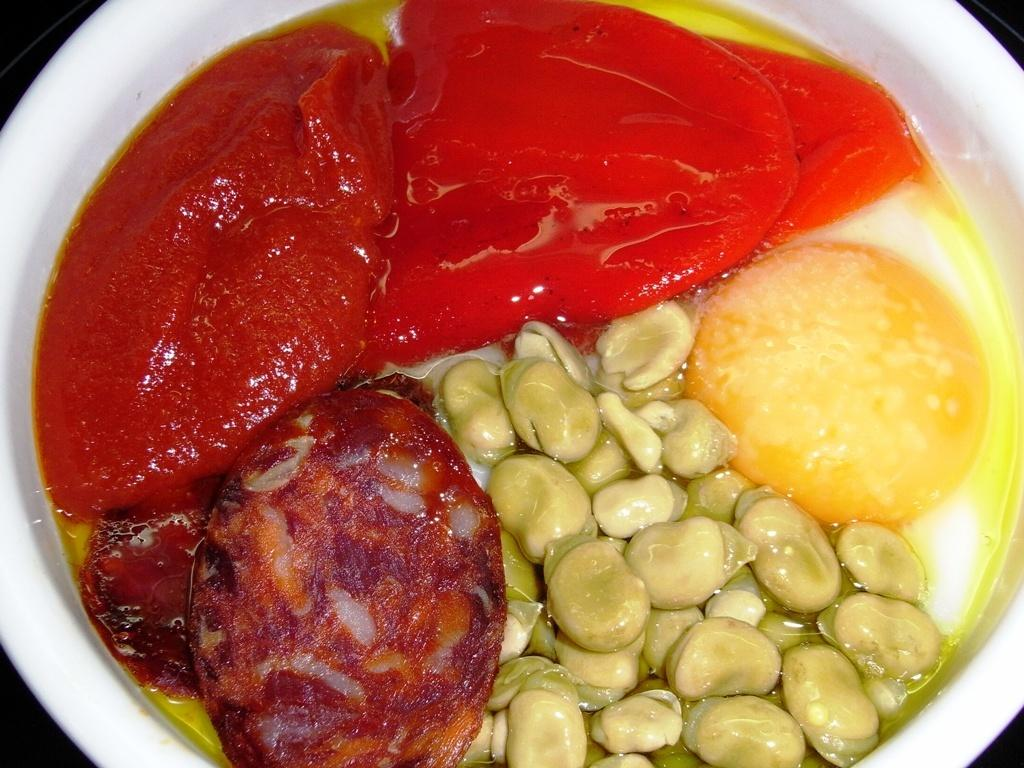What type of objects can be seen in the image? There are food items in the image. How are the food items arranged or contained? The food items are kept in a white-colored bowl. What degree of difficulty is required to prepare the food items in the image? The degree of difficulty in preparing the food items cannot be determined from the image alone, as it only shows the food items in a white-colored bowl. 